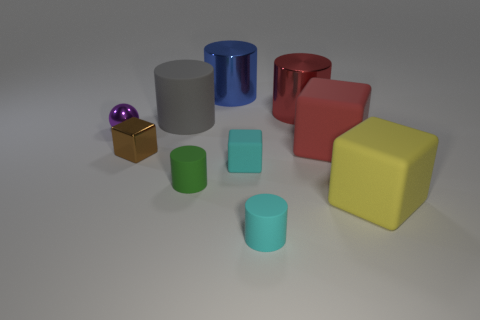What number of objects are either cylinders that are in front of the yellow object or large matte things to the right of the small rubber cube?
Offer a terse response. 3. There is a red shiny object that is the same size as the gray rubber cylinder; what shape is it?
Offer a very short reply. Cylinder. There is a red object in front of the rubber cylinder behind the large red object that is in front of the gray rubber object; what is its shape?
Offer a terse response. Cube. Are there the same number of matte cylinders that are to the left of the large blue metal cylinder and big metallic cylinders?
Give a very brief answer. Yes. Do the purple metallic thing and the blue metal cylinder have the same size?
Offer a very short reply. No. How many shiny things are red cubes or small cylinders?
Make the answer very short. 0. What is the material of the yellow thing that is the same size as the blue object?
Offer a terse response. Rubber. What number of other things are the same material as the big gray object?
Your answer should be very brief. 5. Are there fewer small matte blocks behind the large red metal object than blocks?
Offer a terse response. Yes. Is the big yellow rubber thing the same shape as the blue object?
Ensure brevity in your answer.  No. 